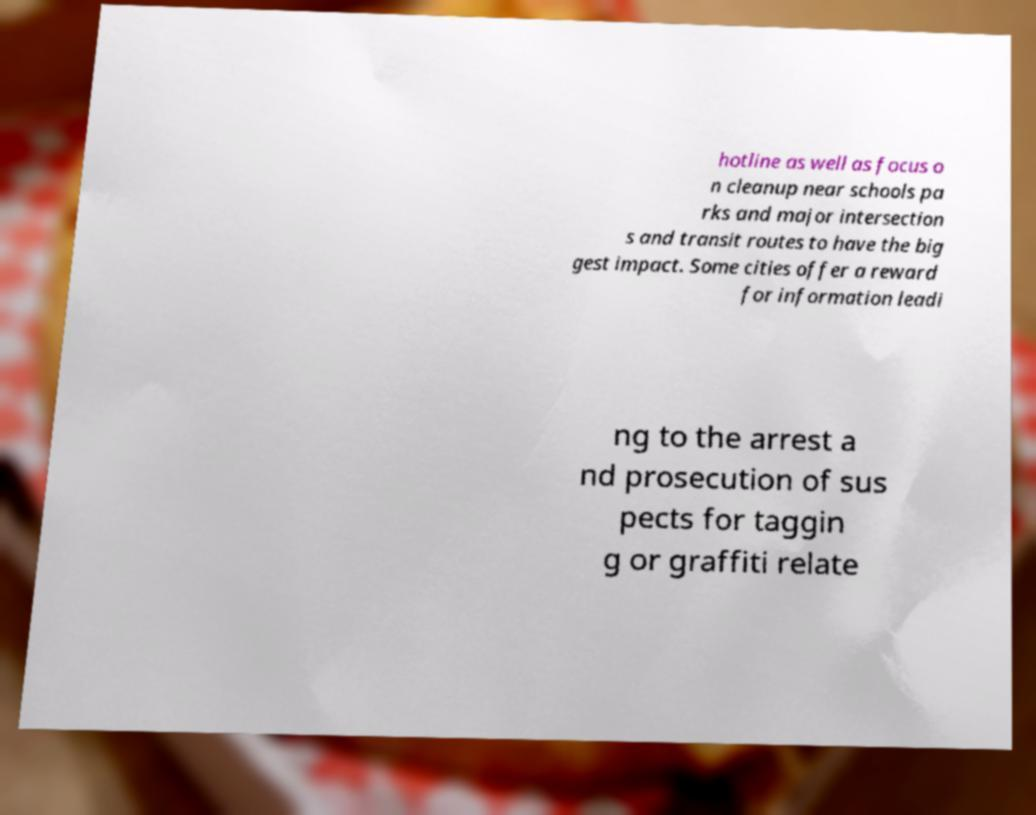Please read and relay the text visible in this image. What does it say? hotline as well as focus o n cleanup near schools pa rks and major intersection s and transit routes to have the big gest impact. Some cities offer a reward for information leadi ng to the arrest a nd prosecution of sus pects for taggin g or graffiti relate 